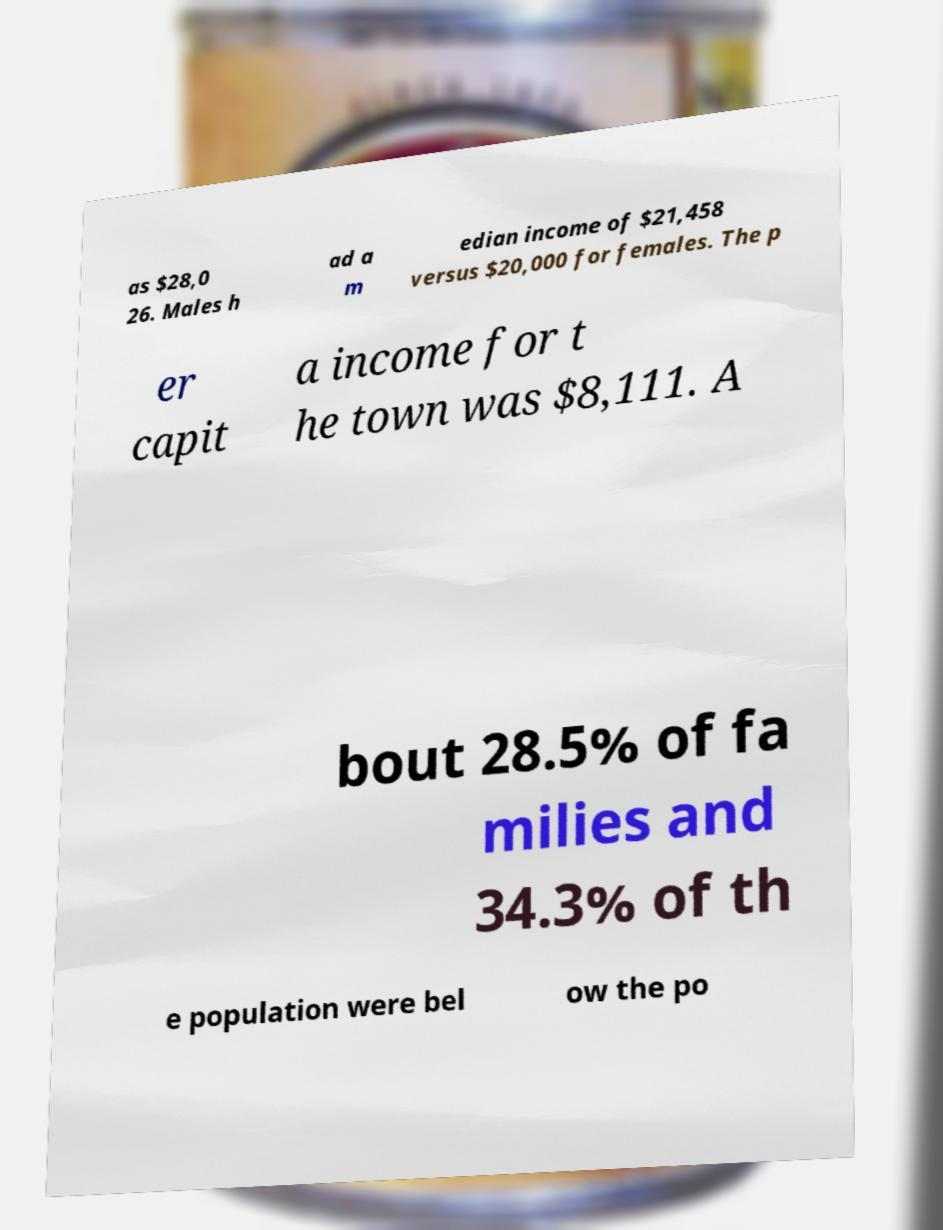Can you read and provide the text displayed in the image?This photo seems to have some interesting text. Can you extract and type it out for me? as $28,0 26. Males h ad a m edian income of $21,458 versus $20,000 for females. The p er capit a income for t he town was $8,111. A bout 28.5% of fa milies and 34.3% of th e population were bel ow the po 